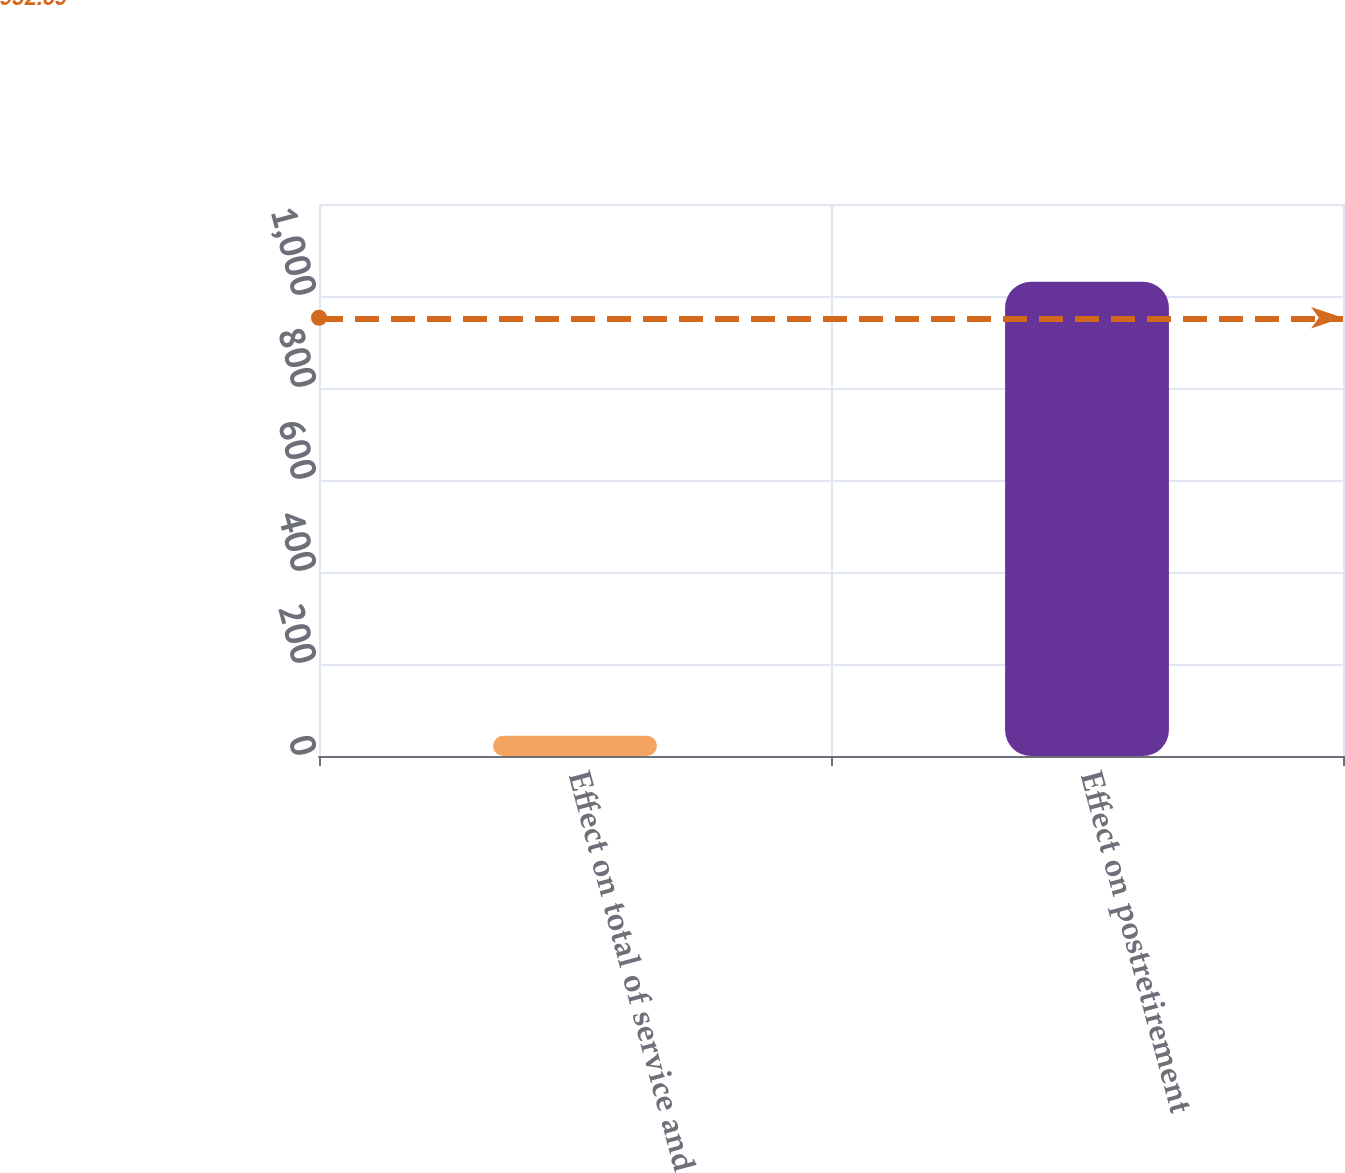<chart> <loc_0><loc_0><loc_500><loc_500><bar_chart><fcel>Effect on total of service and<fcel>Effect on postretirement<nl><fcel>44<fcel>1031<nl></chart> 